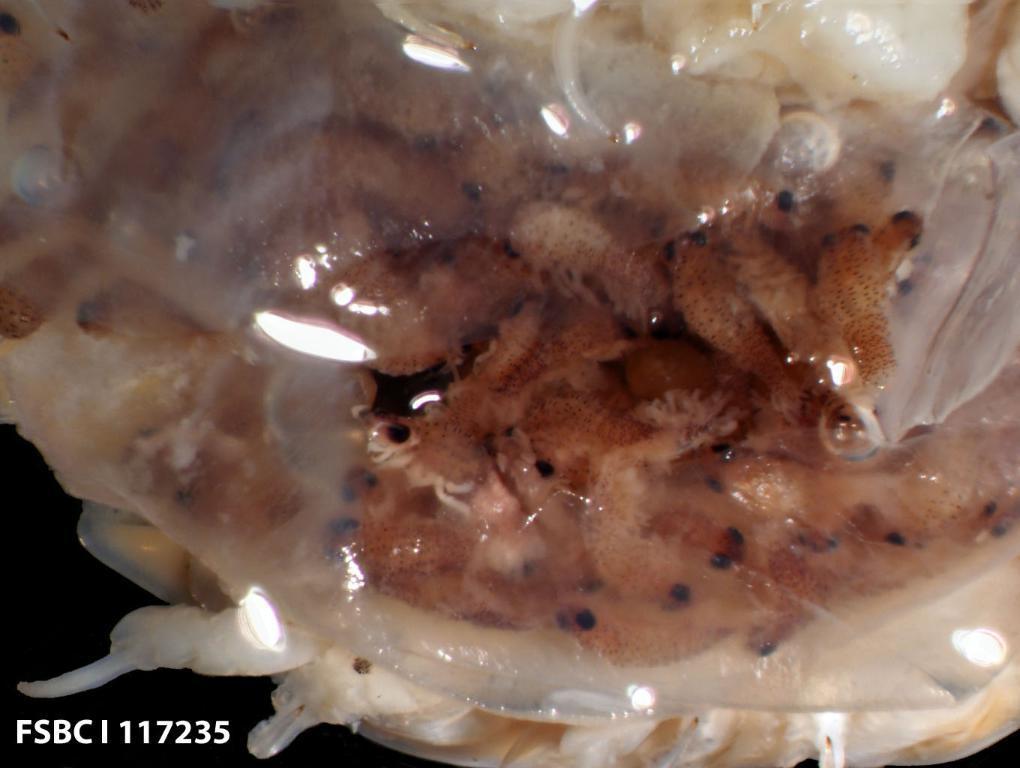How would you summarize this image in a sentence or two? In this image we can see fishes. 